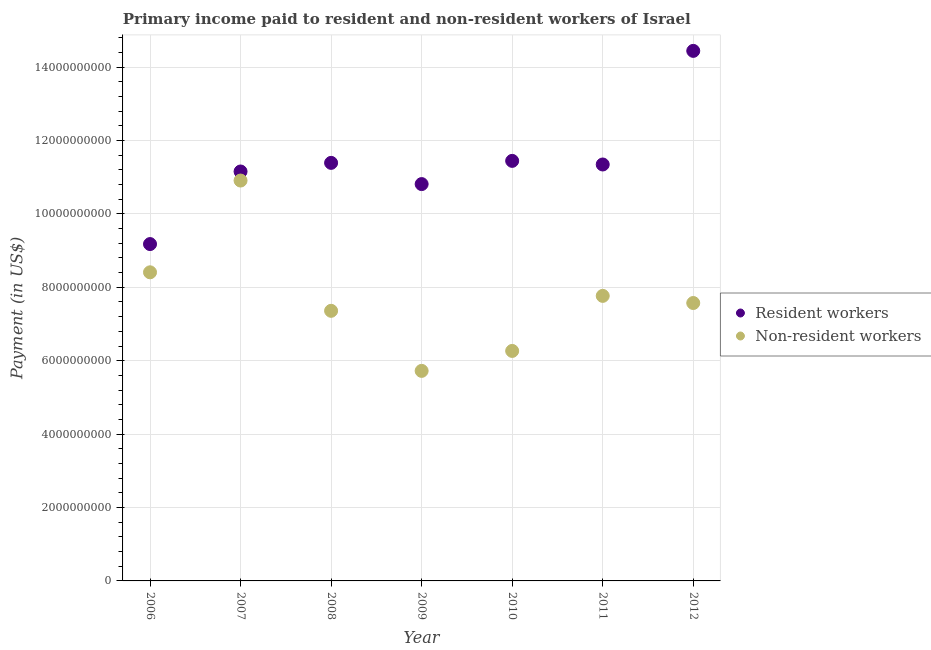How many different coloured dotlines are there?
Offer a very short reply. 2. Is the number of dotlines equal to the number of legend labels?
Ensure brevity in your answer.  Yes. What is the payment made to non-resident workers in 2009?
Provide a succinct answer. 5.72e+09. Across all years, what is the maximum payment made to resident workers?
Offer a very short reply. 1.44e+1. Across all years, what is the minimum payment made to non-resident workers?
Your response must be concise. 5.72e+09. In which year was the payment made to non-resident workers maximum?
Your answer should be compact. 2007. In which year was the payment made to resident workers minimum?
Provide a short and direct response. 2006. What is the total payment made to resident workers in the graph?
Offer a very short reply. 7.98e+1. What is the difference between the payment made to non-resident workers in 2010 and that in 2011?
Ensure brevity in your answer.  -1.50e+09. What is the difference between the payment made to non-resident workers in 2007 and the payment made to resident workers in 2009?
Keep it short and to the point. 9.64e+07. What is the average payment made to non-resident workers per year?
Your answer should be compact. 7.71e+09. In the year 2008, what is the difference between the payment made to resident workers and payment made to non-resident workers?
Offer a terse response. 4.03e+09. What is the ratio of the payment made to non-resident workers in 2006 to that in 2011?
Your answer should be compact. 1.08. Is the payment made to resident workers in 2008 less than that in 2009?
Keep it short and to the point. No. Is the difference between the payment made to resident workers in 2007 and 2010 greater than the difference between the payment made to non-resident workers in 2007 and 2010?
Your answer should be compact. No. What is the difference between the highest and the second highest payment made to resident workers?
Your answer should be compact. 3.00e+09. What is the difference between the highest and the lowest payment made to non-resident workers?
Ensure brevity in your answer.  5.19e+09. In how many years, is the payment made to non-resident workers greater than the average payment made to non-resident workers taken over all years?
Ensure brevity in your answer.  3. Does the payment made to non-resident workers monotonically increase over the years?
Your answer should be very brief. No. Is the payment made to non-resident workers strictly less than the payment made to resident workers over the years?
Provide a short and direct response. Yes. Are the values on the major ticks of Y-axis written in scientific E-notation?
Make the answer very short. No. How many legend labels are there?
Your response must be concise. 2. What is the title of the graph?
Your response must be concise. Primary income paid to resident and non-resident workers of Israel. What is the label or title of the Y-axis?
Give a very brief answer. Payment (in US$). What is the Payment (in US$) of Resident workers in 2006?
Your response must be concise. 9.18e+09. What is the Payment (in US$) of Non-resident workers in 2006?
Your answer should be very brief. 8.41e+09. What is the Payment (in US$) in Resident workers in 2007?
Offer a very short reply. 1.12e+1. What is the Payment (in US$) of Non-resident workers in 2007?
Provide a short and direct response. 1.09e+1. What is the Payment (in US$) of Resident workers in 2008?
Make the answer very short. 1.14e+1. What is the Payment (in US$) of Non-resident workers in 2008?
Provide a short and direct response. 7.36e+09. What is the Payment (in US$) of Resident workers in 2009?
Offer a terse response. 1.08e+1. What is the Payment (in US$) of Non-resident workers in 2009?
Your answer should be compact. 5.72e+09. What is the Payment (in US$) of Resident workers in 2010?
Keep it short and to the point. 1.14e+1. What is the Payment (in US$) in Non-resident workers in 2010?
Your answer should be very brief. 6.27e+09. What is the Payment (in US$) in Resident workers in 2011?
Your response must be concise. 1.13e+1. What is the Payment (in US$) in Non-resident workers in 2011?
Give a very brief answer. 7.77e+09. What is the Payment (in US$) of Resident workers in 2012?
Ensure brevity in your answer.  1.44e+1. What is the Payment (in US$) in Non-resident workers in 2012?
Provide a short and direct response. 7.57e+09. Across all years, what is the maximum Payment (in US$) in Resident workers?
Give a very brief answer. 1.44e+1. Across all years, what is the maximum Payment (in US$) of Non-resident workers?
Ensure brevity in your answer.  1.09e+1. Across all years, what is the minimum Payment (in US$) of Resident workers?
Give a very brief answer. 9.18e+09. Across all years, what is the minimum Payment (in US$) of Non-resident workers?
Your response must be concise. 5.72e+09. What is the total Payment (in US$) in Resident workers in the graph?
Offer a very short reply. 7.98e+1. What is the total Payment (in US$) of Non-resident workers in the graph?
Make the answer very short. 5.40e+1. What is the difference between the Payment (in US$) of Resident workers in 2006 and that in 2007?
Offer a terse response. -1.98e+09. What is the difference between the Payment (in US$) in Non-resident workers in 2006 and that in 2007?
Your answer should be very brief. -2.50e+09. What is the difference between the Payment (in US$) in Resident workers in 2006 and that in 2008?
Your answer should be very brief. -2.21e+09. What is the difference between the Payment (in US$) in Non-resident workers in 2006 and that in 2008?
Your answer should be compact. 1.05e+09. What is the difference between the Payment (in US$) of Resident workers in 2006 and that in 2009?
Your response must be concise. -1.63e+09. What is the difference between the Payment (in US$) in Non-resident workers in 2006 and that in 2009?
Your answer should be compact. 2.69e+09. What is the difference between the Payment (in US$) of Resident workers in 2006 and that in 2010?
Keep it short and to the point. -2.27e+09. What is the difference between the Payment (in US$) in Non-resident workers in 2006 and that in 2010?
Offer a very short reply. 2.14e+09. What is the difference between the Payment (in US$) in Resident workers in 2006 and that in 2011?
Give a very brief answer. -2.17e+09. What is the difference between the Payment (in US$) in Non-resident workers in 2006 and that in 2011?
Give a very brief answer. 6.42e+08. What is the difference between the Payment (in US$) of Resident workers in 2006 and that in 2012?
Give a very brief answer. -5.26e+09. What is the difference between the Payment (in US$) in Non-resident workers in 2006 and that in 2012?
Keep it short and to the point. 8.36e+08. What is the difference between the Payment (in US$) in Resident workers in 2007 and that in 2008?
Keep it short and to the point. -2.35e+08. What is the difference between the Payment (in US$) in Non-resident workers in 2007 and that in 2008?
Offer a very short reply. 3.55e+09. What is the difference between the Payment (in US$) of Resident workers in 2007 and that in 2009?
Your response must be concise. 3.43e+08. What is the difference between the Payment (in US$) in Non-resident workers in 2007 and that in 2009?
Your response must be concise. 5.19e+09. What is the difference between the Payment (in US$) of Resident workers in 2007 and that in 2010?
Your answer should be very brief. -2.89e+08. What is the difference between the Payment (in US$) in Non-resident workers in 2007 and that in 2010?
Your answer should be very brief. 4.64e+09. What is the difference between the Payment (in US$) in Resident workers in 2007 and that in 2011?
Provide a short and direct response. -1.91e+08. What is the difference between the Payment (in US$) of Non-resident workers in 2007 and that in 2011?
Provide a succinct answer. 3.14e+09. What is the difference between the Payment (in US$) in Resident workers in 2007 and that in 2012?
Offer a very short reply. -3.29e+09. What is the difference between the Payment (in US$) of Non-resident workers in 2007 and that in 2012?
Your response must be concise. 3.34e+09. What is the difference between the Payment (in US$) of Resident workers in 2008 and that in 2009?
Keep it short and to the point. 5.78e+08. What is the difference between the Payment (in US$) in Non-resident workers in 2008 and that in 2009?
Provide a short and direct response. 1.64e+09. What is the difference between the Payment (in US$) of Resident workers in 2008 and that in 2010?
Make the answer very short. -5.44e+07. What is the difference between the Payment (in US$) in Non-resident workers in 2008 and that in 2010?
Make the answer very short. 1.09e+09. What is the difference between the Payment (in US$) of Resident workers in 2008 and that in 2011?
Provide a succinct answer. 4.39e+07. What is the difference between the Payment (in US$) of Non-resident workers in 2008 and that in 2011?
Make the answer very short. -4.07e+08. What is the difference between the Payment (in US$) in Resident workers in 2008 and that in 2012?
Offer a very short reply. -3.05e+09. What is the difference between the Payment (in US$) in Non-resident workers in 2008 and that in 2012?
Make the answer very short. -2.13e+08. What is the difference between the Payment (in US$) in Resident workers in 2009 and that in 2010?
Ensure brevity in your answer.  -6.32e+08. What is the difference between the Payment (in US$) in Non-resident workers in 2009 and that in 2010?
Your answer should be compact. -5.44e+08. What is the difference between the Payment (in US$) in Resident workers in 2009 and that in 2011?
Make the answer very short. -5.34e+08. What is the difference between the Payment (in US$) in Non-resident workers in 2009 and that in 2011?
Provide a short and direct response. -2.04e+09. What is the difference between the Payment (in US$) in Resident workers in 2009 and that in 2012?
Keep it short and to the point. -3.63e+09. What is the difference between the Payment (in US$) in Non-resident workers in 2009 and that in 2012?
Give a very brief answer. -1.85e+09. What is the difference between the Payment (in US$) in Resident workers in 2010 and that in 2011?
Make the answer very short. 9.83e+07. What is the difference between the Payment (in US$) of Non-resident workers in 2010 and that in 2011?
Keep it short and to the point. -1.50e+09. What is the difference between the Payment (in US$) in Resident workers in 2010 and that in 2012?
Your response must be concise. -3.00e+09. What is the difference between the Payment (in US$) in Non-resident workers in 2010 and that in 2012?
Provide a succinct answer. -1.31e+09. What is the difference between the Payment (in US$) in Resident workers in 2011 and that in 2012?
Ensure brevity in your answer.  -3.10e+09. What is the difference between the Payment (in US$) of Non-resident workers in 2011 and that in 2012?
Offer a very short reply. 1.94e+08. What is the difference between the Payment (in US$) in Resident workers in 2006 and the Payment (in US$) in Non-resident workers in 2007?
Ensure brevity in your answer.  -1.73e+09. What is the difference between the Payment (in US$) in Resident workers in 2006 and the Payment (in US$) in Non-resident workers in 2008?
Provide a short and direct response. 1.82e+09. What is the difference between the Payment (in US$) in Resident workers in 2006 and the Payment (in US$) in Non-resident workers in 2009?
Your response must be concise. 3.46e+09. What is the difference between the Payment (in US$) of Resident workers in 2006 and the Payment (in US$) of Non-resident workers in 2010?
Keep it short and to the point. 2.91e+09. What is the difference between the Payment (in US$) of Resident workers in 2006 and the Payment (in US$) of Non-resident workers in 2011?
Keep it short and to the point. 1.41e+09. What is the difference between the Payment (in US$) in Resident workers in 2006 and the Payment (in US$) in Non-resident workers in 2012?
Ensure brevity in your answer.  1.61e+09. What is the difference between the Payment (in US$) of Resident workers in 2007 and the Payment (in US$) of Non-resident workers in 2008?
Offer a very short reply. 3.80e+09. What is the difference between the Payment (in US$) of Resident workers in 2007 and the Payment (in US$) of Non-resident workers in 2009?
Make the answer very short. 5.43e+09. What is the difference between the Payment (in US$) in Resident workers in 2007 and the Payment (in US$) in Non-resident workers in 2010?
Provide a succinct answer. 4.89e+09. What is the difference between the Payment (in US$) of Resident workers in 2007 and the Payment (in US$) of Non-resident workers in 2011?
Offer a terse response. 3.39e+09. What is the difference between the Payment (in US$) of Resident workers in 2007 and the Payment (in US$) of Non-resident workers in 2012?
Your answer should be very brief. 3.58e+09. What is the difference between the Payment (in US$) of Resident workers in 2008 and the Payment (in US$) of Non-resident workers in 2009?
Provide a short and direct response. 5.67e+09. What is the difference between the Payment (in US$) in Resident workers in 2008 and the Payment (in US$) in Non-resident workers in 2010?
Your answer should be very brief. 5.12e+09. What is the difference between the Payment (in US$) of Resident workers in 2008 and the Payment (in US$) of Non-resident workers in 2011?
Your answer should be very brief. 3.62e+09. What is the difference between the Payment (in US$) in Resident workers in 2008 and the Payment (in US$) in Non-resident workers in 2012?
Provide a succinct answer. 3.82e+09. What is the difference between the Payment (in US$) of Resident workers in 2009 and the Payment (in US$) of Non-resident workers in 2010?
Provide a succinct answer. 4.55e+09. What is the difference between the Payment (in US$) of Resident workers in 2009 and the Payment (in US$) of Non-resident workers in 2011?
Your answer should be compact. 3.05e+09. What is the difference between the Payment (in US$) of Resident workers in 2009 and the Payment (in US$) of Non-resident workers in 2012?
Your response must be concise. 3.24e+09. What is the difference between the Payment (in US$) of Resident workers in 2010 and the Payment (in US$) of Non-resident workers in 2011?
Keep it short and to the point. 3.68e+09. What is the difference between the Payment (in US$) in Resident workers in 2010 and the Payment (in US$) in Non-resident workers in 2012?
Keep it short and to the point. 3.87e+09. What is the difference between the Payment (in US$) in Resident workers in 2011 and the Payment (in US$) in Non-resident workers in 2012?
Your response must be concise. 3.77e+09. What is the average Payment (in US$) of Resident workers per year?
Your answer should be compact. 1.14e+1. What is the average Payment (in US$) of Non-resident workers per year?
Keep it short and to the point. 7.71e+09. In the year 2006, what is the difference between the Payment (in US$) in Resident workers and Payment (in US$) in Non-resident workers?
Your answer should be very brief. 7.69e+08. In the year 2007, what is the difference between the Payment (in US$) in Resident workers and Payment (in US$) in Non-resident workers?
Ensure brevity in your answer.  2.47e+08. In the year 2008, what is the difference between the Payment (in US$) of Resident workers and Payment (in US$) of Non-resident workers?
Provide a short and direct response. 4.03e+09. In the year 2009, what is the difference between the Payment (in US$) of Resident workers and Payment (in US$) of Non-resident workers?
Give a very brief answer. 5.09e+09. In the year 2010, what is the difference between the Payment (in US$) of Resident workers and Payment (in US$) of Non-resident workers?
Keep it short and to the point. 5.18e+09. In the year 2011, what is the difference between the Payment (in US$) in Resident workers and Payment (in US$) in Non-resident workers?
Provide a short and direct response. 3.58e+09. In the year 2012, what is the difference between the Payment (in US$) in Resident workers and Payment (in US$) in Non-resident workers?
Offer a very short reply. 6.87e+09. What is the ratio of the Payment (in US$) in Resident workers in 2006 to that in 2007?
Provide a short and direct response. 0.82. What is the ratio of the Payment (in US$) in Non-resident workers in 2006 to that in 2007?
Provide a succinct answer. 0.77. What is the ratio of the Payment (in US$) in Resident workers in 2006 to that in 2008?
Give a very brief answer. 0.81. What is the ratio of the Payment (in US$) in Non-resident workers in 2006 to that in 2008?
Provide a succinct answer. 1.14. What is the ratio of the Payment (in US$) in Resident workers in 2006 to that in 2009?
Offer a very short reply. 0.85. What is the ratio of the Payment (in US$) of Non-resident workers in 2006 to that in 2009?
Your answer should be compact. 1.47. What is the ratio of the Payment (in US$) of Resident workers in 2006 to that in 2010?
Offer a very short reply. 0.8. What is the ratio of the Payment (in US$) in Non-resident workers in 2006 to that in 2010?
Ensure brevity in your answer.  1.34. What is the ratio of the Payment (in US$) in Resident workers in 2006 to that in 2011?
Offer a very short reply. 0.81. What is the ratio of the Payment (in US$) of Non-resident workers in 2006 to that in 2011?
Give a very brief answer. 1.08. What is the ratio of the Payment (in US$) in Resident workers in 2006 to that in 2012?
Your answer should be compact. 0.64. What is the ratio of the Payment (in US$) in Non-resident workers in 2006 to that in 2012?
Your answer should be very brief. 1.11. What is the ratio of the Payment (in US$) in Resident workers in 2007 to that in 2008?
Keep it short and to the point. 0.98. What is the ratio of the Payment (in US$) in Non-resident workers in 2007 to that in 2008?
Offer a terse response. 1.48. What is the ratio of the Payment (in US$) of Resident workers in 2007 to that in 2009?
Your response must be concise. 1.03. What is the ratio of the Payment (in US$) in Non-resident workers in 2007 to that in 2009?
Your answer should be very brief. 1.91. What is the ratio of the Payment (in US$) in Resident workers in 2007 to that in 2010?
Offer a very short reply. 0.97. What is the ratio of the Payment (in US$) of Non-resident workers in 2007 to that in 2010?
Your answer should be compact. 1.74. What is the ratio of the Payment (in US$) of Resident workers in 2007 to that in 2011?
Give a very brief answer. 0.98. What is the ratio of the Payment (in US$) of Non-resident workers in 2007 to that in 2011?
Provide a short and direct response. 1.4. What is the ratio of the Payment (in US$) in Resident workers in 2007 to that in 2012?
Your answer should be compact. 0.77. What is the ratio of the Payment (in US$) of Non-resident workers in 2007 to that in 2012?
Your answer should be compact. 1.44. What is the ratio of the Payment (in US$) in Resident workers in 2008 to that in 2009?
Your answer should be compact. 1.05. What is the ratio of the Payment (in US$) in Non-resident workers in 2008 to that in 2009?
Your response must be concise. 1.29. What is the ratio of the Payment (in US$) of Resident workers in 2008 to that in 2010?
Make the answer very short. 1. What is the ratio of the Payment (in US$) in Non-resident workers in 2008 to that in 2010?
Offer a very short reply. 1.17. What is the ratio of the Payment (in US$) of Non-resident workers in 2008 to that in 2011?
Make the answer very short. 0.95. What is the ratio of the Payment (in US$) of Resident workers in 2008 to that in 2012?
Your answer should be compact. 0.79. What is the ratio of the Payment (in US$) in Non-resident workers in 2008 to that in 2012?
Provide a short and direct response. 0.97. What is the ratio of the Payment (in US$) in Resident workers in 2009 to that in 2010?
Make the answer very short. 0.94. What is the ratio of the Payment (in US$) of Non-resident workers in 2009 to that in 2010?
Provide a short and direct response. 0.91. What is the ratio of the Payment (in US$) in Resident workers in 2009 to that in 2011?
Offer a very short reply. 0.95. What is the ratio of the Payment (in US$) of Non-resident workers in 2009 to that in 2011?
Your answer should be compact. 0.74. What is the ratio of the Payment (in US$) of Resident workers in 2009 to that in 2012?
Provide a short and direct response. 0.75. What is the ratio of the Payment (in US$) of Non-resident workers in 2009 to that in 2012?
Give a very brief answer. 0.76. What is the ratio of the Payment (in US$) of Resident workers in 2010 to that in 2011?
Keep it short and to the point. 1.01. What is the ratio of the Payment (in US$) of Non-resident workers in 2010 to that in 2011?
Make the answer very short. 0.81. What is the ratio of the Payment (in US$) in Resident workers in 2010 to that in 2012?
Give a very brief answer. 0.79. What is the ratio of the Payment (in US$) of Non-resident workers in 2010 to that in 2012?
Your answer should be very brief. 0.83. What is the ratio of the Payment (in US$) of Resident workers in 2011 to that in 2012?
Provide a succinct answer. 0.79. What is the ratio of the Payment (in US$) of Non-resident workers in 2011 to that in 2012?
Your answer should be very brief. 1.03. What is the difference between the highest and the second highest Payment (in US$) in Resident workers?
Your answer should be very brief. 3.00e+09. What is the difference between the highest and the second highest Payment (in US$) in Non-resident workers?
Offer a very short reply. 2.50e+09. What is the difference between the highest and the lowest Payment (in US$) of Resident workers?
Make the answer very short. 5.26e+09. What is the difference between the highest and the lowest Payment (in US$) of Non-resident workers?
Ensure brevity in your answer.  5.19e+09. 